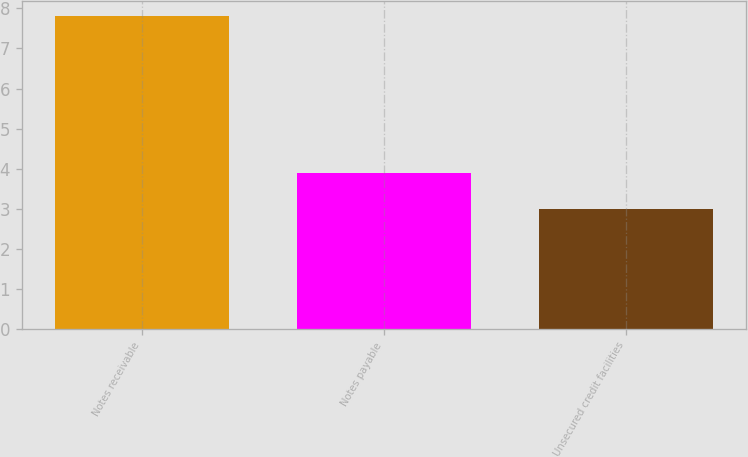<chart> <loc_0><loc_0><loc_500><loc_500><bar_chart><fcel>Notes receivable<fcel>Notes payable<fcel>Unsecured credit facilities<nl><fcel>7.8<fcel>3.9<fcel>3<nl></chart> 